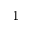Convert formula to latex. <formula><loc_0><loc_0><loc_500><loc_500>_ { 1 }</formula> 